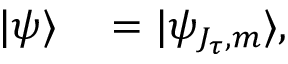<formula> <loc_0><loc_0><loc_500><loc_500>\begin{array} { r l } { | \psi \rangle } & = | \psi _ { J _ { \tau } , m } \rangle , } \end{array}</formula> 